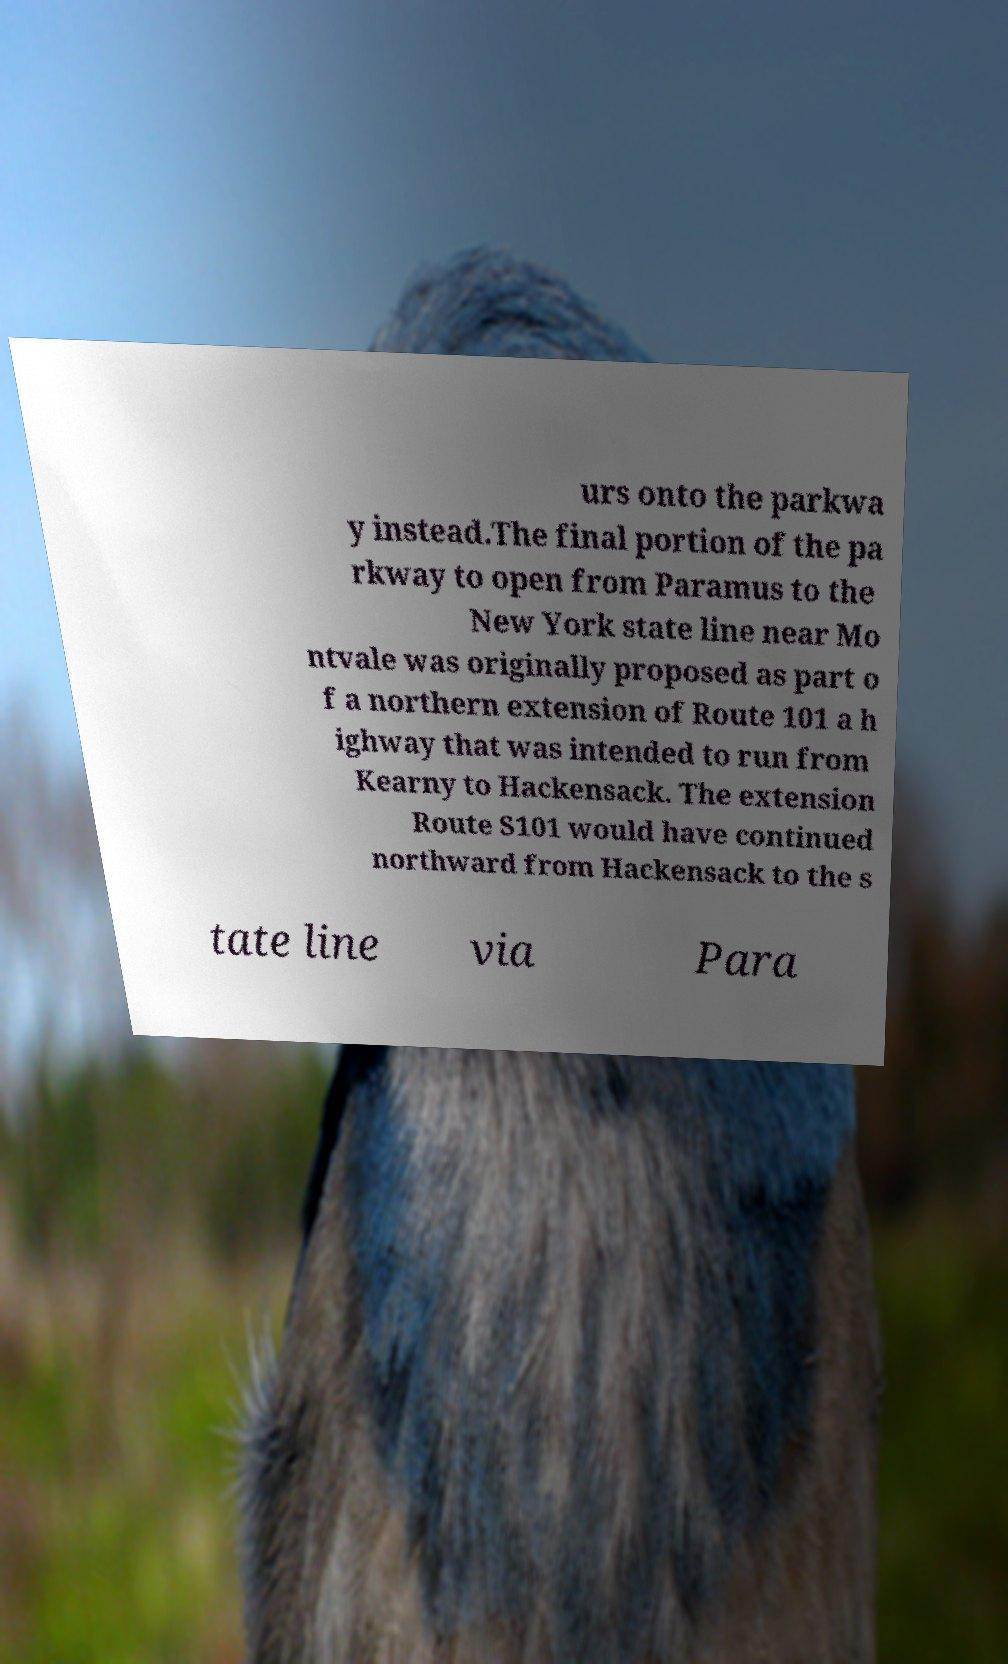What messages or text are displayed in this image? I need them in a readable, typed format. urs onto the parkwa y instead.The final portion of the pa rkway to open from Paramus to the New York state line near Mo ntvale was originally proposed as part o f a northern extension of Route 101 a h ighway that was intended to run from Kearny to Hackensack. The extension Route S101 would have continued northward from Hackensack to the s tate line via Para 